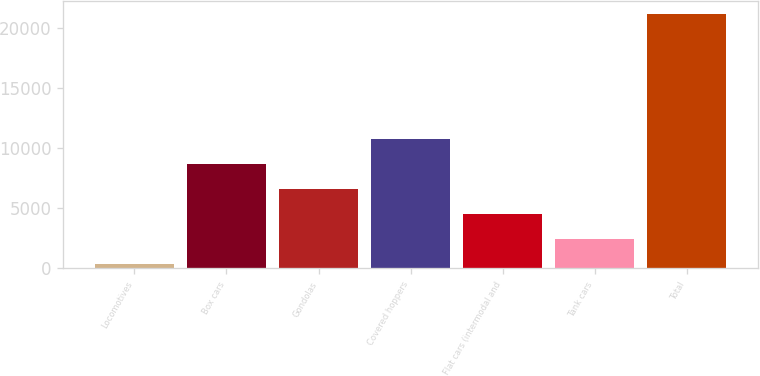<chart> <loc_0><loc_0><loc_500><loc_500><bar_chart><fcel>Locomotives<fcel>Box cars<fcel>Gondolas<fcel>Covered hoppers<fcel>Flat cars (intermodal and<fcel>Tank cars<fcel>Total<nl><fcel>385<fcel>8707.8<fcel>6627.1<fcel>10788.5<fcel>4546.4<fcel>2465.7<fcel>21192<nl></chart> 